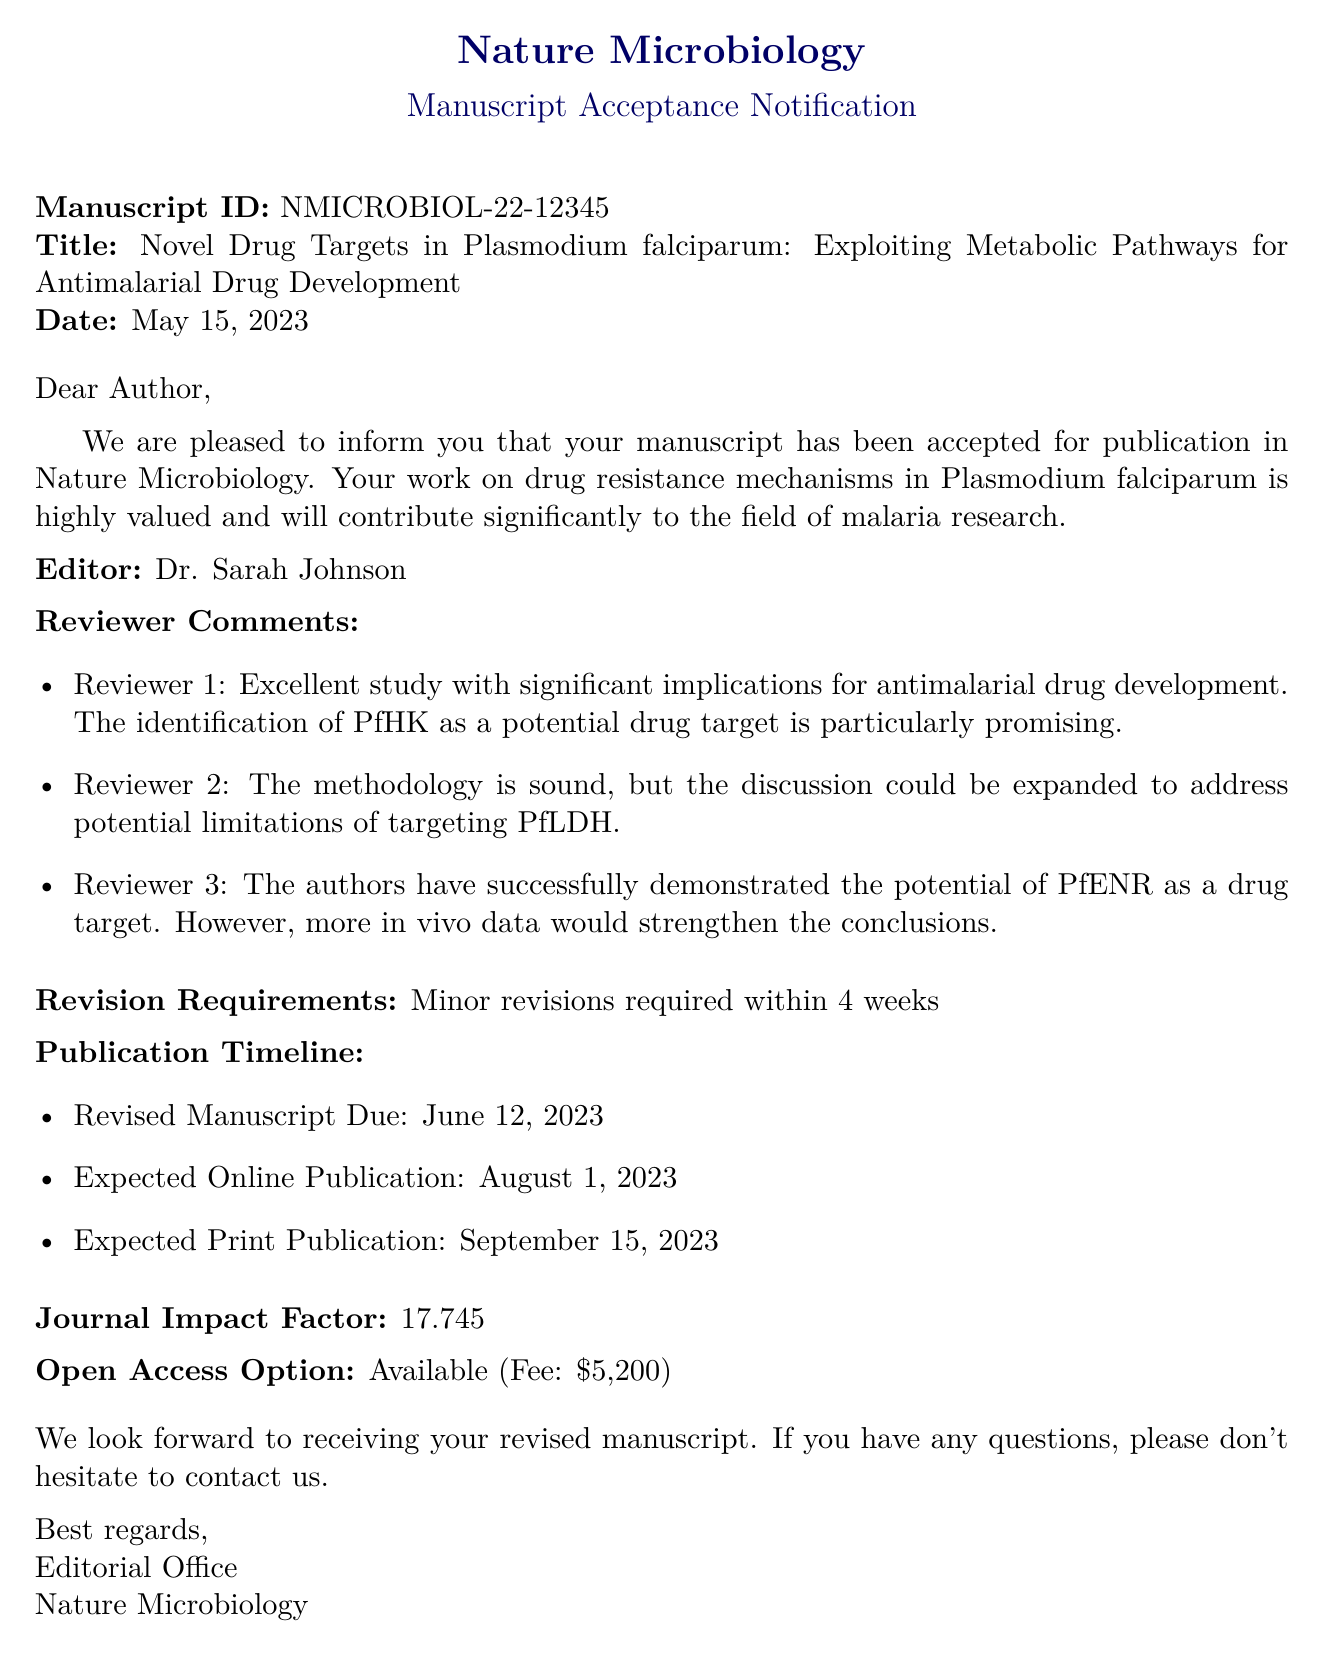What is the manuscript ID? The manuscript ID is mentioned prominently to identify the submission, which helps in tracking its progress.
Answer: NMICROBIOL-22-12345 Who is the editor of the manuscript? The document specifies the name of the editor overseeing the manuscript's review and acceptance.
Answer: Dr. Sarah Johnson What are the minor revisions required by the reviewers? The revisions requested by the reviewers must be addressed in the revised manuscript submission.
Answer: Minor revisions required What is the expected online publication date? The publication timeline includes expected dates for the online and print versions of the manuscript.
Answer: August 1, 2023 What is the impact factor of the journal? The impact factor indicates the journal's reputation and the average citations per article, a key parameter for researchers.
Answer: 17.745 What is the due date for the revised manuscript? The document states the deadline for submitting the revised version of the manuscript after minor revisions.
Answer: June 12, 2023 How many reviewers provided comments? The document lists feedback from multiple reviewers regarding the manuscript's content and methodology.
Answer: 3 What is the open access fee for the publication? The open access option is presented along with its corresponding fee, which can be important for funding considerations.
Answer: $5,200 What were the main strengths noted by Reviewer 1? The reviewers provide insights into the strengths and weaknesses of the research, showcasing its contributions.
Answer: Identification of PfHK as a potential drug target 